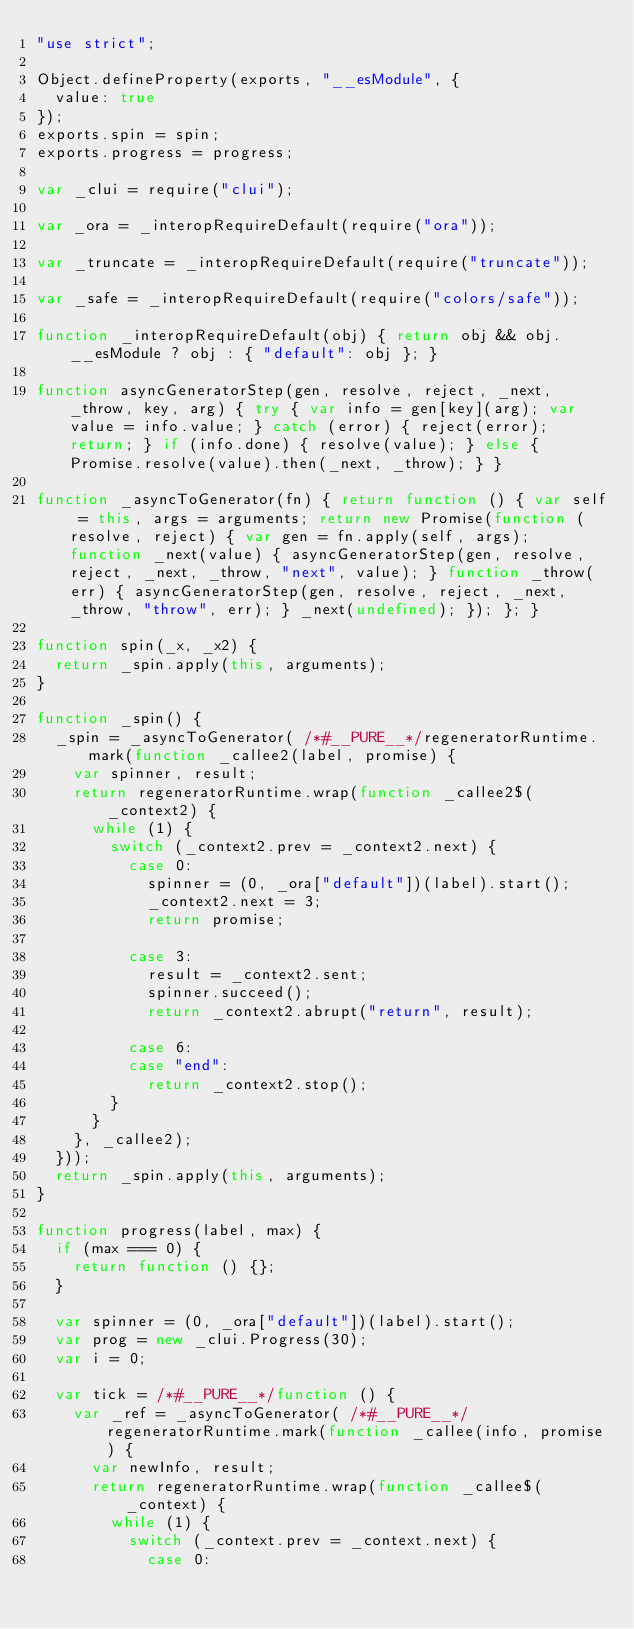<code> <loc_0><loc_0><loc_500><loc_500><_JavaScript_>"use strict";

Object.defineProperty(exports, "__esModule", {
  value: true
});
exports.spin = spin;
exports.progress = progress;

var _clui = require("clui");

var _ora = _interopRequireDefault(require("ora"));

var _truncate = _interopRequireDefault(require("truncate"));

var _safe = _interopRequireDefault(require("colors/safe"));

function _interopRequireDefault(obj) { return obj && obj.__esModule ? obj : { "default": obj }; }

function asyncGeneratorStep(gen, resolve, reject, _next, _throw, key, arg) { try { var info = gen[key](arg); var value = info.value; } catch (error) { reject(error); return; } if (info.done) { resolve(value); } else { Promise.resolve(value).then(_next, _throw); } }

function _asyncToGenerator(fn) { return function () { var self = this, args = arguments; return new Promise(function (resolve, reject) { var gen = fn.apply(self, args); function _next(value) { asyncGeneratorStep(gen, resolve, reject, _next, _throw, "next", value); } function _throw(err) { asyncGeneratorStep(gen, resolve, reject, _next, _throw, "throw", err); } _next(undefined); }); }; }

function spin(_x, _x2) {
  return _spin.apply(this, arguments);
}

function _spin() {
  _spin = _asyncToGenerator( /*#__PURE__*/regeneratorRuntime.mark(function _callee2(label, promise) {
    var spinner, result;
    return regeneratorRuntime.wrap(function _callee2$(_context2) {
      while (1) {
        switch (_context2.prev = _context2.next) {
          case 0:
            spinner = (0, _ora["default"])(label).start();
            _context2.next = 3;
            return promise;

          case 3:
            result = _context2.sent;
            spinner.succeed();
            return _context2.abrupt("return", result);

          case 6:
          case "end":
            return _context2.stop();
        }
      }
    }, _callee2);
  }));
  return _spin.apply(this, arguments);
}

function progress(label, max) {
  if (max === 0) {
    return function () {};
  }

  var spinner = (0, _ora["default"])(label).start();
  var prog = new _clui.Progress(30);
  var i = 0;

  var tick = /*#__PURE__*/function () {
    var _ref = _asyncToGenerator( /*#__PURE__*/regeneratorRuntime.mark(function _callee(info, promise) {
      var newInfo, result;
      return regeneratorRuntime.wrap(function _callee$(_context) {
        while (1) {
          switch (_context.prev = _context.next) {
            case 0:</code> 